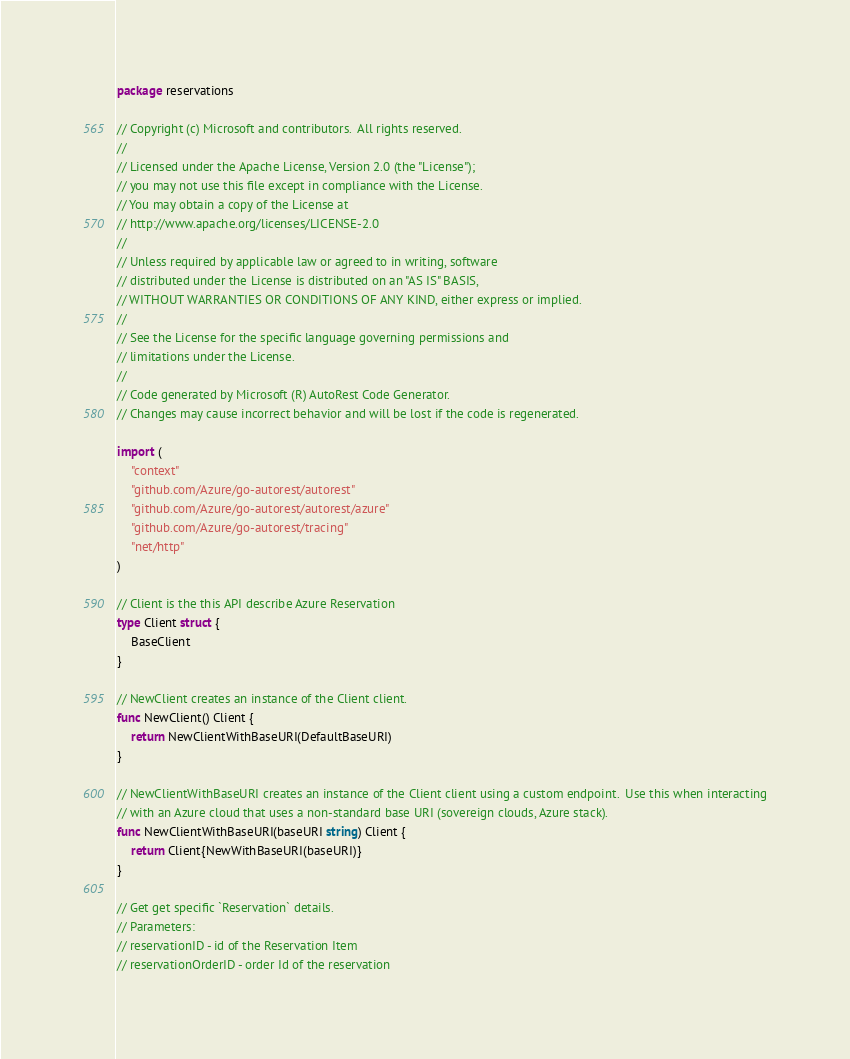Convert code to text. <code><loc_0><loc_0><loc_500><loc_500><_Go_>package reservations

// Copyright (c) Microsoft and contributors.  All rights reserved.
//
// Licensed under the Apache License, Version 2.0 (the "License");
// you may not use this file except in compliance with the License.
// You may obtain a copy of the License at
// http://www.apache.org/licenses/LICENSE-2.0
//
// Unless required by applicable law or agreed to in writing, software
// distributed under the License is distributed on an "AS IS" BASIS,
// WITHOUT WARRANTIES OR CONDITIONS OF ANY KIND, either express or implied.
//
// See the License for the specific language governing permissions and
// limitations under the License.
//
// Code generated by Microsoft (R) AutoRest Code Generator.
// Changes may cause incorrect behavior and will be lost if the code is regenerated.

import (
	"context"
	"github.com/Azure/go-autorest/autorest"
	"github.com/Azure/go-autorest/autorest/azure"
	"github.com/Azure/go-autorest/tracing"
	"net/http"
)

// Client is the this API describe Azure Reservation
type Client struct {
	BaseClient
}

// NewClient creates an instance of the Client client.
func NewClient() Client {
	return NewClientWithBaseURI(DefaultBaseURI)
}

// NewClientWithBaseURI creates an instance of the Client client using a custom endpoint.  Use this when interacting
// with an Azure cloud that uses a non-standard base URI (sovereign clouds, Azure stack).
func NewClientWithBaseURI(baseURI string) Client {
	return Client{NewWithBaseURI(baseURI)}
}

// Get get specific `Reservation` details.
// Parameters:
// reservationID - id of the Reservation Item
// reservationOrderID - order Id of the reservation</code> 